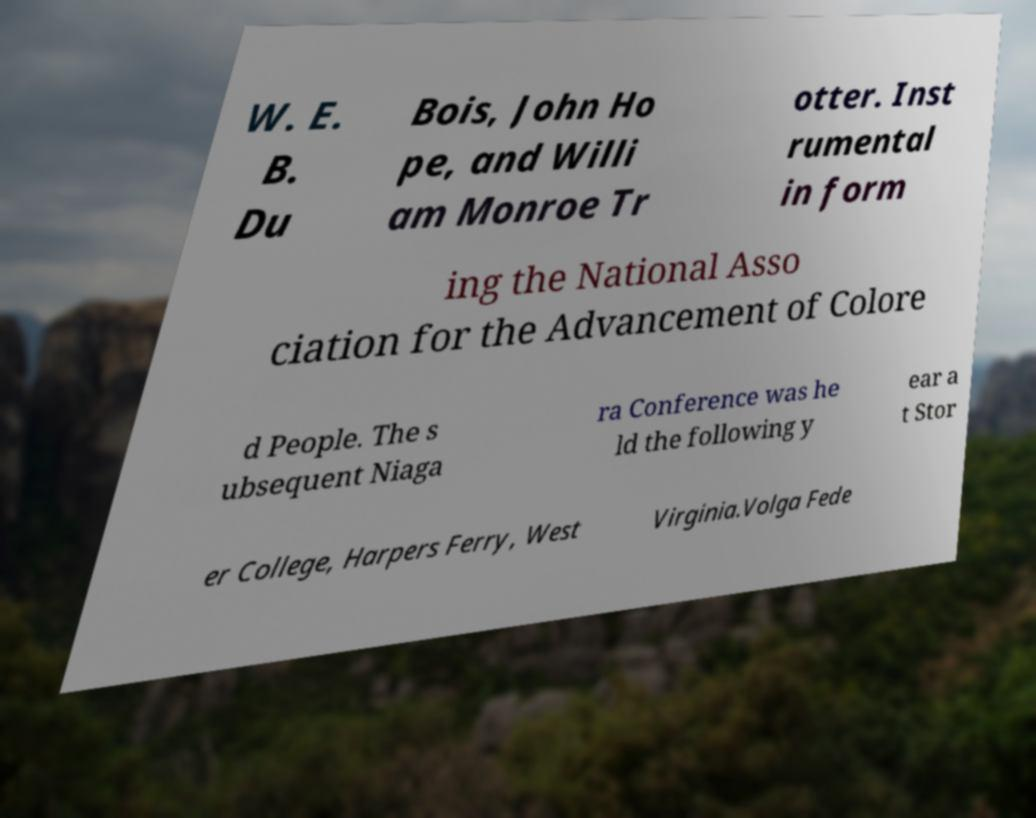What messages or text are displayed in this image? I need them in a readable, typed format. W. E. B. Du Bois, John Ho pe, and Willi am Monroe Tr otter. Inst rumental in form ing the National Asso ciation for the Advancement of Colore d People. The s ubsequent Niaga ra Conference was he ld the following y ear a t Stor er College, Harpers Ferry, West Virginia.Volga Fede 